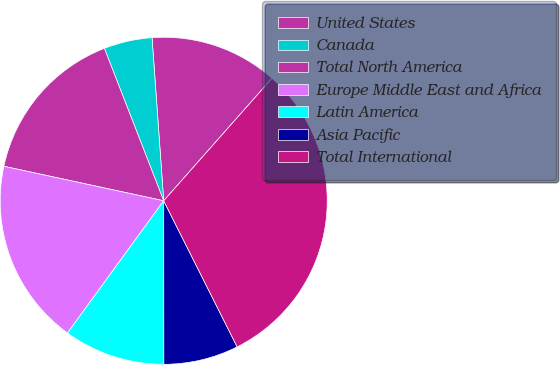<chart> <loc_0><loc_0><loc_500><loc_500><pie_chart><fcel>United States<fcel>Canada<fcel>Total North America<fcel>Europe Middle East and Africa<fcel>Latin America<fcel>Asia Pacific<fcel>Total International<nl><fcel>12.66%<fcel>4.77%<fcel>15.71%<fcel>18.37%<fcel>10.03%<fcel>7.4%<fcel>31.06%<nl></chart> 